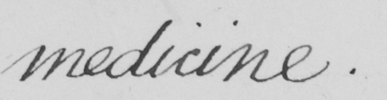Please provide the text content of this handwritten line. medicine. 